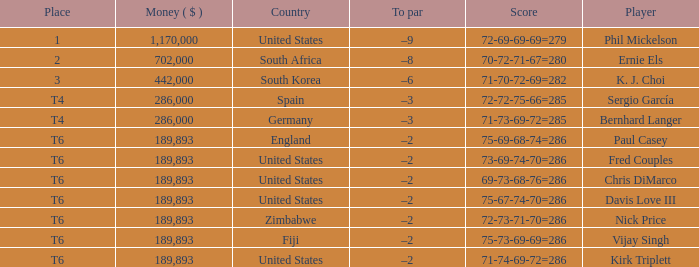What is the most money ($) when the score is 71-74-69-72=286? 189893.0. 